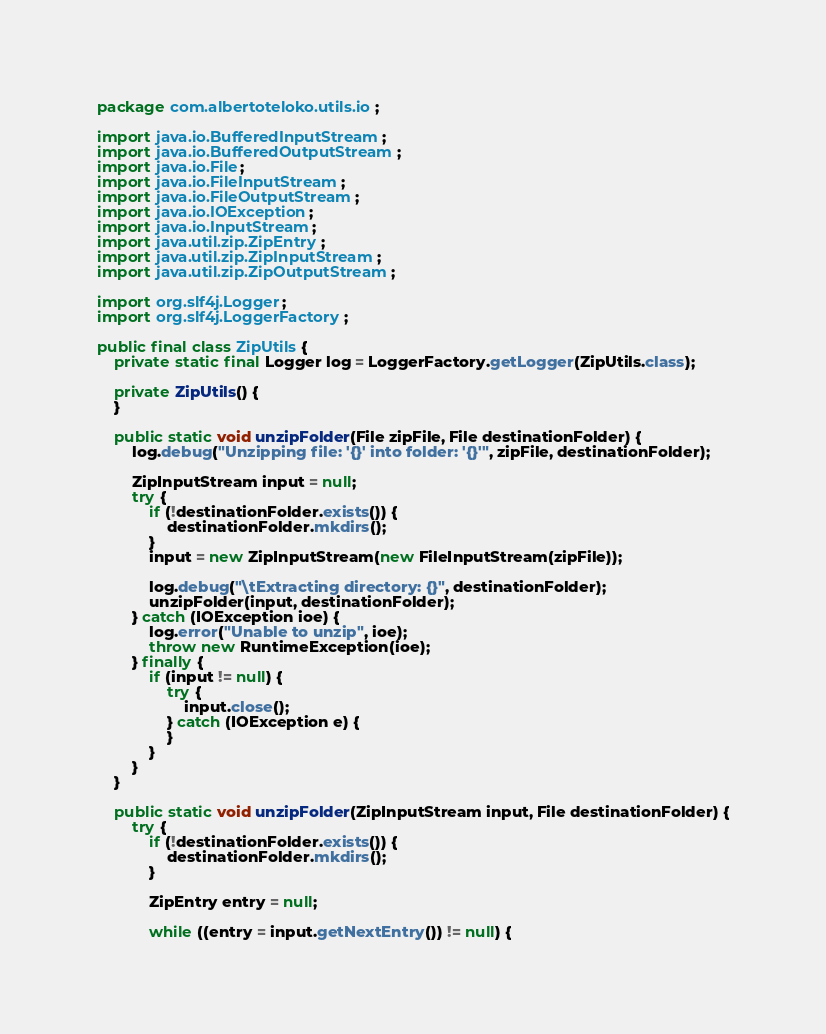Convert code to text. <code><loc_0><loc_0><loc_500><loc_500><_Java_>package com.albertoteloko.utils.io;

import java.io.BufferedInputStream;
import java.io.BufferedOutputStream;
import java.io.File;
import java.io.FileInputStream;
import java.io.FileOutputStream;
import java.io.IOException;
import java.io.InputStream;
import java.util.zip.ZipEntry;
import java.util.zip.ZipInputStream;
import java.util.zip.ZipOutputStream;

import org.slf4j.Logger;
import org.slf4j.LoggerFactory;

public final class ZipUtils {
	private static final Logger log = LoggerFactory.getLogger(ZipUtils.class);

	private ZipUtils() {
	}

	public static void unzipFolder(File zipFile, File destinationFolder) {
		log.debug("Unzipping file: '{}' into folder: '{}'", zipFile, destinationFolder);

		ZipInputStream input = null;
		try {
			if (!destinationFolder.exists()) {
				destinationFolder.mkdirs();
			}
			input = new ZipInputStream(new FileInputStream(zipFile));

			log.debug("\tExtracting directory: {}", destinationFolder);
			unzipFolder(input, destinationFolder);
		} catch (IOException ioe) {
			log.error("Unable to unzip", ioe);
			throw new RuntimeException(ioe);
		} finally {
			if (input != null) {
				try {
					input.close();
				} catch (IOException e) {
				}
			}
		}
	}

	public static void unzipFolder(ZipInputStream input, File destinationFolder) {
		try {
			if (!destinationFolder.exists()) {
				destinationFolder.mkdirs();
			}

			ZipEntry entry = null;

			while ((entry = input.getNextEntry()) != null) {</code> 